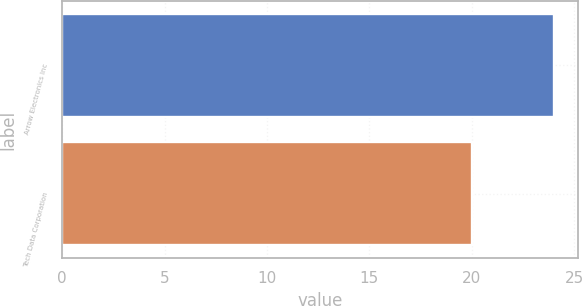Convert chart. <chart><loc_0><loc_0><loc_500><loc_500><bar_chart><fcel>Arrow Electronics Inc<fcel>Tech Data Corporation<nl><fcel>24<fcel>20<nl></chart> 